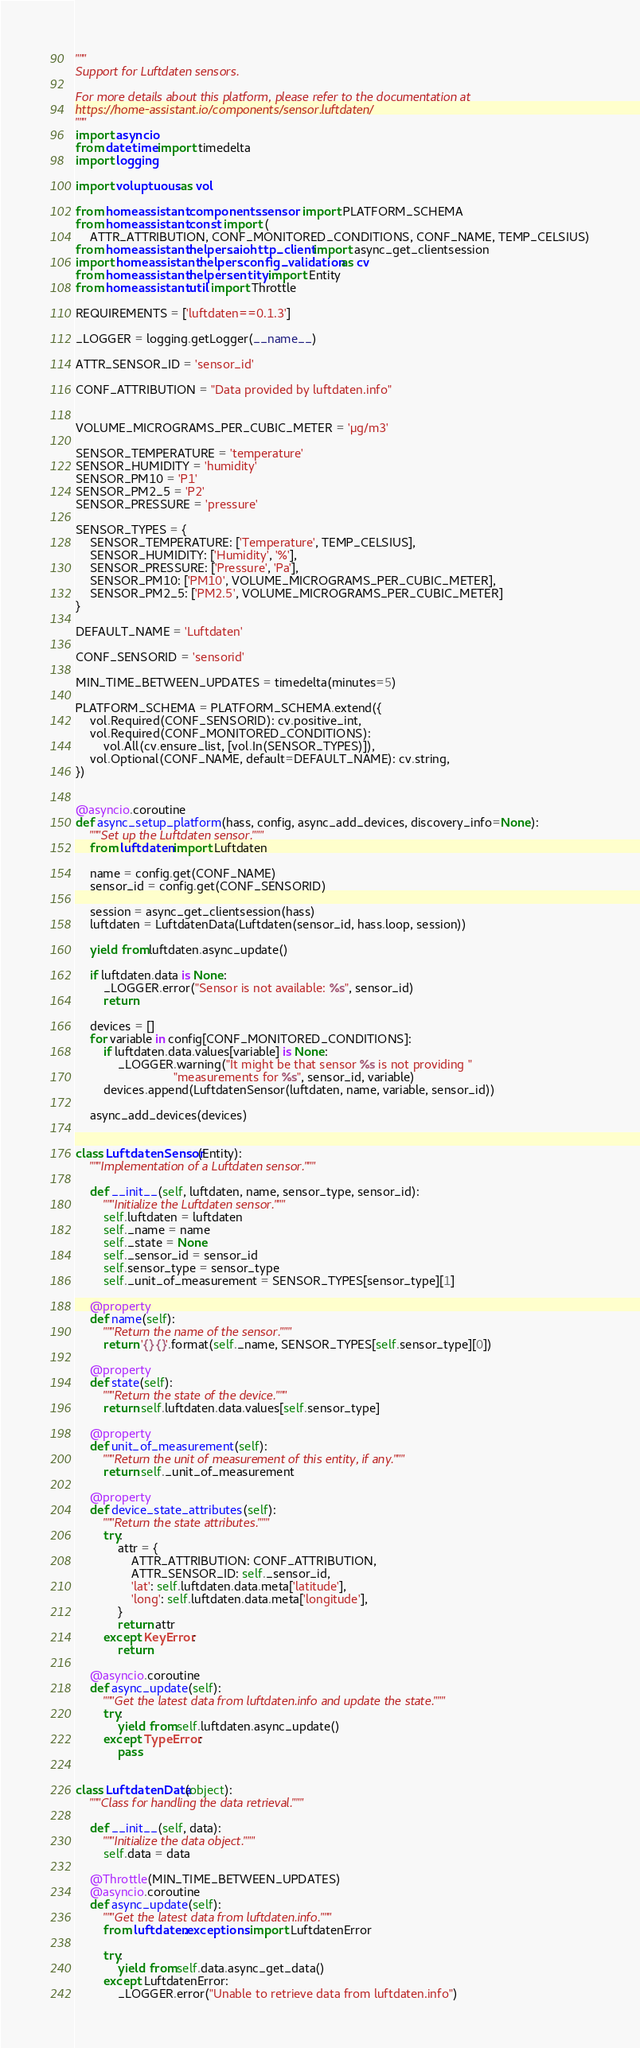Convert code to text. <code><loc_0><loc_0><loc_500><loc_500><_Python_>"""
Support for Luftdaten sensors.

For more details about this platform, please refer to the documentation at
https://home-assistant.io/components/sensor.luftdaten/
"""
import asyncio
from datetime import timedelta
import logging

import voluptuous as vol

from homeassistant.components.sensor import PLATFORM_SCHEMA
from homeassistant.const import (
    ATTR_ATTRIBUTION, CONF_MONITORED_CONDITIONS, CONF_NAME, TEMP_CELSIUS)
from homeassistant.helpers.aiohttp_client import async_get_clientsession
import homeassistant.helpers.config_validation as cv
from homeassistant.helpers.entity import Entity
from homeassistant.util import Throttle

REQUIREMENTS = ['luftdaten==0.1.3']

_LOGGER = logging.getLogger(__name__)

ATTR_SENSOR_ID = 'sensor_id'

CONF_ATTRIBUTION = "Data provided by luftdaten.info"


VOLUME_MICROGRAMS_PER_CUBIC_METER = 'µg/m3'

SENSOR_TEMPERATURE = 'temperature'
SENSOR_HUMIDITY = 'humidity'
SENSOR_PM10 = 'P1'
SENSOR_PM2_5 = 'P2'
SENSOR_PRESSURE = 'pressure'

SENSOR_TYPES = {
    SENSOR_TEMPERATURE: ['Temperature', TEMP_CELSIUS],
    SENSOR_HUMIDITY: ['Humidity', '%'],
    SENSOR_PRESSURE: ['Pressure', 'Pa'],
    SENSOR_PM10: ['PM10', VOLUME_MICROGRAMS_PER_CUBIC_METER],
    SENSOR_PM2_5: ['PM2.5', VOLUME_MICROGRAMS_PER_CUBIC_METER]
}

DEFAULT_NAME = 'Luftdaten'

CONF_SENSORID = 'sensorid'

MIN_TIME_BETWEEN_UPDATES = timedelta(minutes=5)

PLATFORM_SCHEMA = PLATFORM_SCHEMA.extend({
    vol.Required(CONF_SENSORID): cv.positive_int,
    vol.Required(CONF_MONITORED_CONDITIONS):
        vol.All(cv.ensure_list, [vol.In(SENSOR_TYPES)]),
    vol.Optional(CONF_NAME, default=DEFAULT_NAME): cv.string,
})


@asyncio.coroutine
def async_setup_platform(hass, config, async_add_devices, discovery_info=None):
    """Set up the Luftdaten sensor."""
    from luftdaten import Luftdaten

    name = config.get(CONF_NAME)
    sensor_id = config.get(CONF_SENSORID)

    session = async_get_clientsession(hass)
    luftdaten = LuftdatenData(Luftdaten(sensor_id, hass.loop, session))

    yield from luftdaten.async_update()

    if luftdaten.data is None:
        _LOGGER.error("Sensor is not available: %s", sensor_id)
        return

    devices = []
    for variable in config[CONF_MONITORED_CONDITIONS]:
        if luftdaten.data.values[variable] is None:
            _LOGGER.warning("It might be that sensor %s is not providing "
                            "measurements for %s", sensor_id, variable)
        devices.append(LuftdatenSensor(luftdaten, name, variable, sensor_id))

    async_add_devices(devices)


class LuftdatenSensor(Entity):
    """Implementation of a Luftdaten sensor."""

    def __init__(self, luftdaten, name, sensor_type, sensor_id):
        """Initialize the Luftdaten sensor."""
        self.luftdaten = luftdaten
        self._name = name
        self._state = None
        self._sensor_id = sensor_id
        self.sensor_type = sensor_type
        self._unit_of_measurement = SENSOR_TYPES[sensor_type][1]

    @property
    def name(self):
        """Return the name of the sensor."""
        return '{} {}'.format(self._name, SENSOR_TYPES[self.sensor_type][0])

    @property
    def state(self):
        """Return the state of the device."""
        return self.luftdaten.data.values[self.sensor_type]

    @property
    def unit_of_measurement(self):
        """Return the unit of measurement of this entity, if any."""
        return self._unit_of_measurement

    @property
    def device_state_attributes(self):
        """Return the state attributes."""
        try:
            attr = {
                ATTR_ATTRIBUTION: CONF_ATTRIBUTION,
                ATTR_SENSOR_ID: self._sensor_id,
                'lat': self.luftdaten.data.meta['latitude'],
                'long': self.luftdaten.data.meta['longitude'],
            }
            return attr
        except KeyError:
            return

    @asyncio.coroutine
    def async_update(self):
        """Get the latest data from luftdaten.info and update the state."""
        try:
            yield from self.luftdaten.async_update()
        except TypeError:
            pass


class LuftdatenData(object):
    """Class for handling the data retrieval."""

    def __init__(self, data):
        """Initialize the data object."""
        self.data = data

    @Throttle(MIN_TIME_BETWEEN_UPDATES)
    @asyncio.coroutine
    def async_update(self):
        """Get the latest data from luftdaten.info."""
        from luftdaten.exceptions import LuftdatenError

        try:
            yield from self.data.async_get_data()
        except LuftdatenError:
            _LOGGER.error("Unable to retrieve data from luftdaten.info")
</code> 